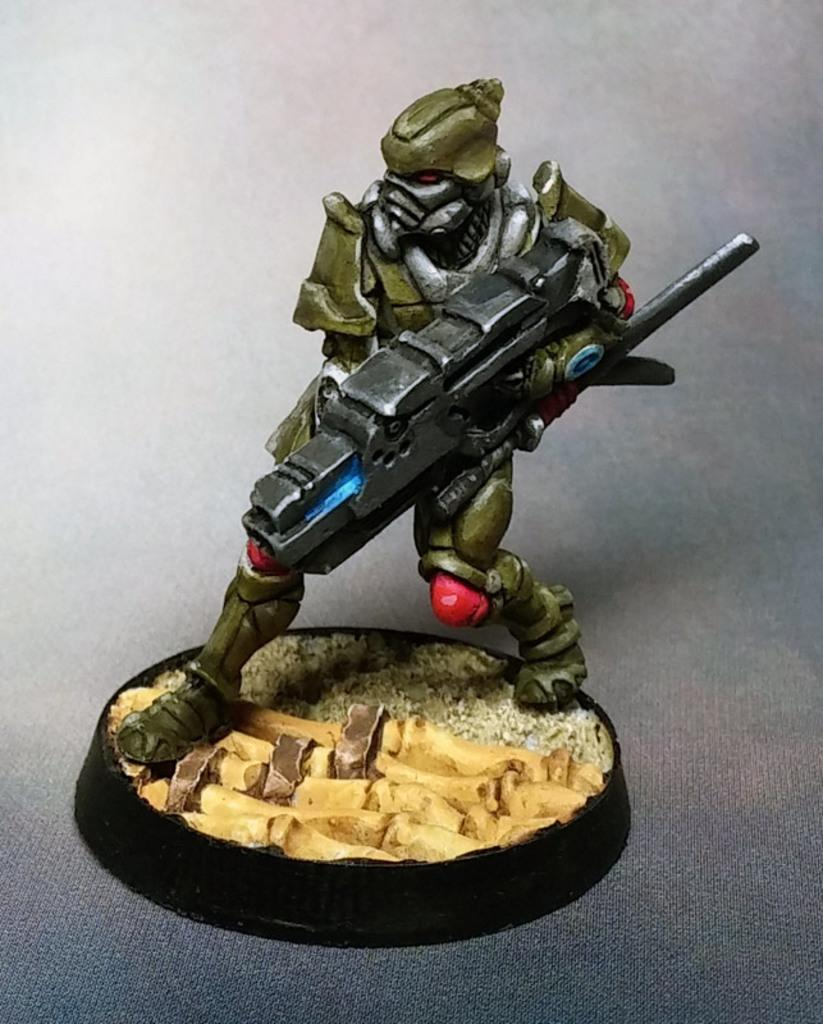What is the main subject of the image? There is a toy robot in the image. Where is the toy robot located in the image? The toy robot is in the center of the image. How many mice are hiding under the toy robot in the image? There are no mice present in the image; it features a toy robot in the center. What type of cherry is placed on top of the toy robot in the image? There is no cherry present on top of the toy robot in the image. 